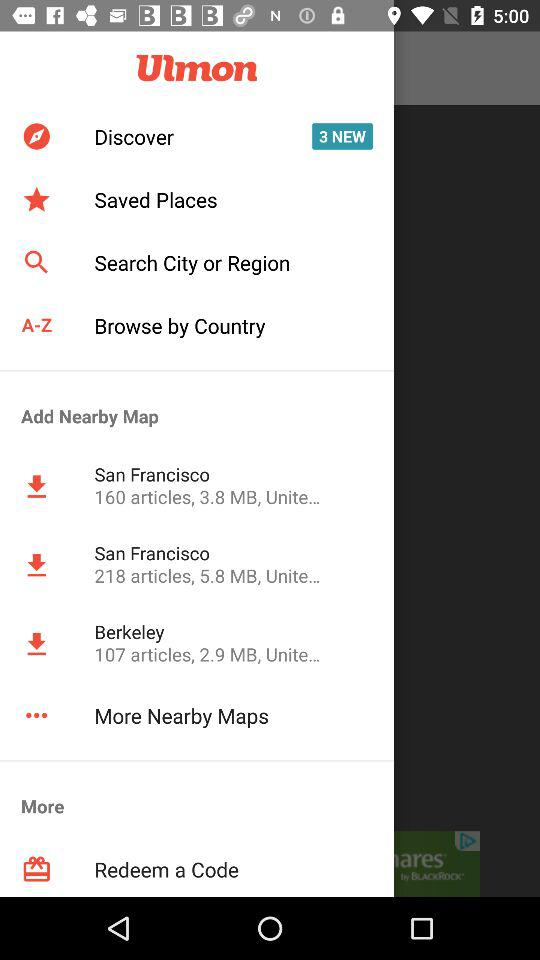What is the company name? The company name is "Ulmon". 